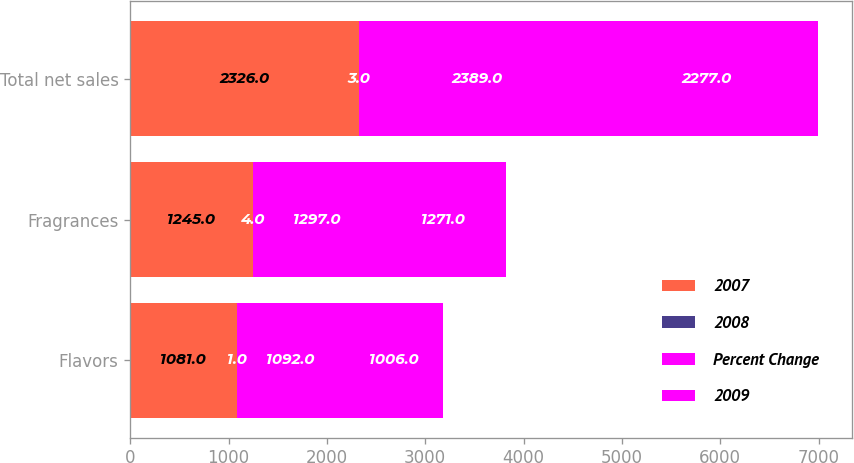<chart> <loc_0><loc_0><loc_500><loc_500><stacked_bar_chart><ecel><fcel>Flavors<fcel>Fragrances<fcel>Total net sales<nl><fcel>2007<fcel>1081<fcel>1245<fcel>2326<nl><fcel>2008<fcel>1<fcel>4<fcel>3<nl><fcel>Percent Change<fcel>1092<fcel>1297<fcel>2389<nl><fcel>2009<fcel>1006<fcel>1271<fcel>2277<nl></chart> 